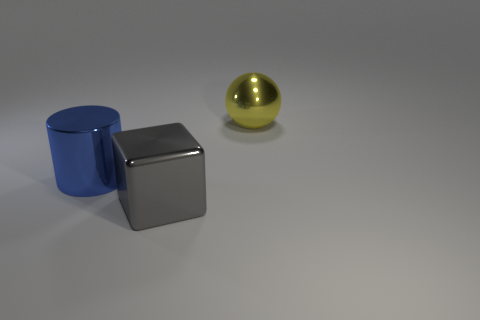Subtract 1 balls. How many balls are left? 0 Subtract all spheres. How many objects are left? 2 Subtract all purple blocks. How many red spheres are left? 0 Subtract all large blue metallic things. Subtract all yellow shiny things. How many objects are left? 1 Add 2 large cylinders. How many large cylinders are left? 3 Add 2 tiny cyan rubber things. How many tiny cyan rubber things exist? 2 Add 2 big blue shiny things. How many objects exist? 5 Subtract 0 purple blocks. How many objects are left? 3 